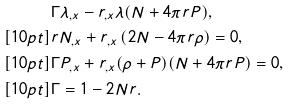Convert formula to latex. <formula><loc_0><loc_0><loc_500><loc_500>& \Gamma \lambda _ { , x } - r _ { , x } \lambda ( N + 4 \pi r P ) , \\ [ 1 0 p t ] & r N _ { , x } + r _ { , x } \left ( 2 N - 4 \pi r \rho \right ) = 0 , \\ [ 1 0 p t ] & \Gamma P _ { , x } + r _ { , x } ( \rho + P ) ( N + 4 \pi r P ) = 0 , \\ [ 1 0 p t ] & \Gamma = 1 - 2 N r .</formula> 